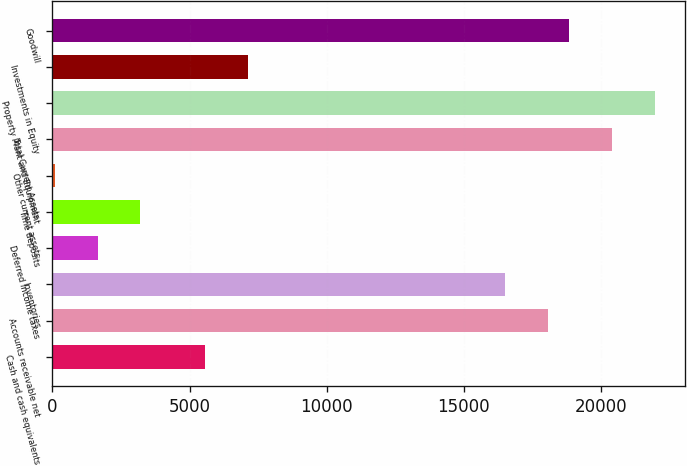Convert chart. <chart><loc_0><loc_0><loc_500><loc_500><bar_chart><fcel>Cash and cash equivalents<fcel>Accounts receivable net<fcel>Inventories<fcel>Deferred income taxes<fcel>Time deposits<fcel>Other current assets<fcel>Total Current Assets<fcel>Property Plant and Equipment<fcel>Investments in Equity<fcel>Goodwill<nl><fcel>5552.12<fcel>18050.7<fcel>16488.4<fcel>1646.32<fcel>3208.64<fcel>84<fcel>20394.2<fcel>21956.5<fcel>7114.44<fcel>18831.8<nl></chart> 